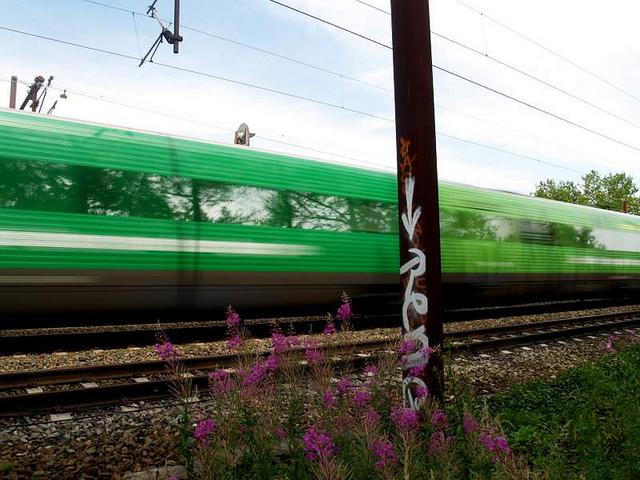What is reflecting off the train?
Concise answer only. Trees. What is pictured moving in the photo?
Give a very brief answer. Train. Are there flowers growing beside the railroad?
Be succinct. Yes. 